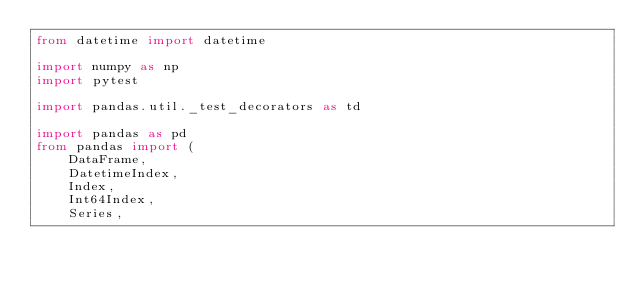<code> <loc_0><loc_0><loc_500><loc_500><_Python_>from datetime import datetime

import numpy as np
import pytest

import pandas.util._test_decorators as td

import pandas as pd
from pandas import (
    DataFrame,
    DatetimeIndex,
    Index,
    Int64Index,
    Series,</code> 